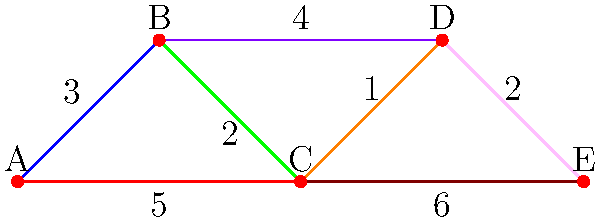In a dance collaboration network, vertices represent different cultural dance styles, and edges represent potential collaborations with weights indicating the complexity of fusion. Given the network above, what is the total complexity (sum of edge weights) of the minimum spanning tree that connects all dance styles for a multicultural fusion performance? To find the minimum spanning tree (MST) of this dance collaboration network, we can use Kruskal's algorithm:

1. Sort all edges by weight in ascending order:
   (C-D, 1), (B-C, 2), (D-E, 2), (A-B, 3), (B-D, 4), (A-C, 5), (C-E, 6)

2. Start with an empty MST and add edges in order, skipping those that would create a cycle:
   - Add (C-D, 1)
   - Add (B-C, 2)
   - Add (D-E, 2)
   - Add (A-B, 3)

3. At this point, we have connected all vertices (dance styles) with 4 edges, forming the MST.

4. Calculate the total complexity by summing the weights of the edges in the MST:
   $1 + 2 + 2 + 3 = 8$

Therefore, the total complexity of the minimum spanning tree is 8.
Answer: 8 